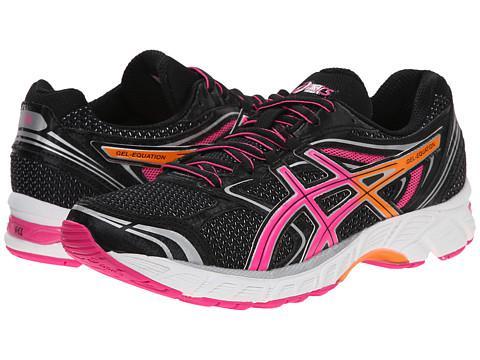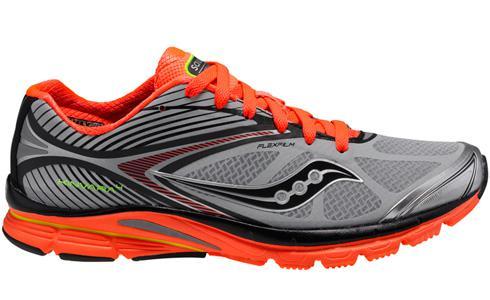The first image is the image on the left, the second image is the image on the right. Considering the images on both sides, is "The shoe style in one image is black with pink and white accents, and tied with black laces with pink edging." valid? Answer yes or no. Yes. The first image is the image on the left, the second image is the image on the right. For the images displayed, is the sentence "Each image contains exactly one athletic shoe shown at an angle." factually correct? Answer yes or no. No. 